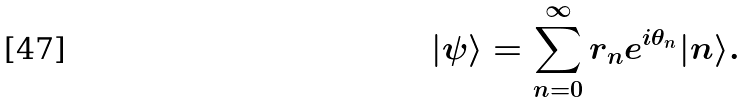<formula> <loc_0><loc_0><loc_500><loc_500>| \psi \rangle = \sum _ { n = 0 } ^ { \infty } r _ { n } e ^ { i \theta _ { n } } | n \rangle .</formula> 